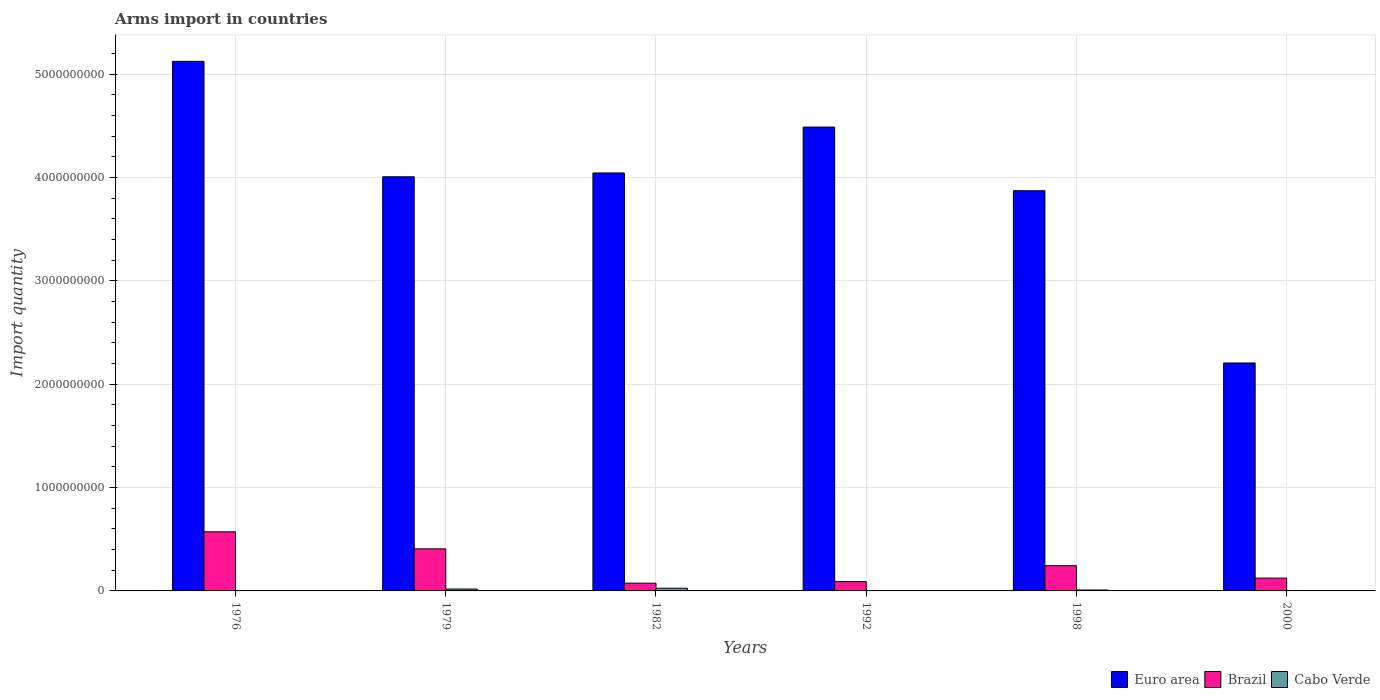How many different coloured bars are there?
Provide a short and direct response. 3. Are the number of bars per tick equal to the number of legend labels?
Your answer should be very brief. Yes. How many bars are there on the 4th tick from the left?
Keep it short and to the point. 3. How many bars are there on the 6th tick from the right?
Provide a succinct answer. 3. What is the label of the 4th group of bars from the left?
Offer a terse response. 1992. In how many cases, is the number of bars for a given year not equal to the number of legend labels?
Keep it short and to the point. 0. What is the total arms import in Brazil in 1982?
Your answer should be compact. 7.50e+07. Across all years, what is the maximum total arms import in Cabo Verde?
Offer a terse response. 2.60e+07. Across all years, what is the minimum total arms import in Euro area?
Provide a succinct answer. 2.21e+09. In which year was the total arms import in Euro area maximum?
Give a very brief answer. 1976. In which year was the total arms import in Euro area minimum?
Offer a terse response. 2000. What is the total total arms import in Brazil in the graph?
Your response must be concise. 1.51e+09. What is the difference between the total arms import in Cabo Verde in 1976 and that in 1982?
Your response must be concise. -2.40e+07. What is the difference between the total arms import in Brazil in 1992 and the total arms import in Euro area in 1979?
Keep it short and to the point. -3.92e+09. What is the average total arms import in Euro area per year?
Your response must be concise. 3.96e+09. In the year 1976, what is the difference between the total arms import in Euro area and total arms import in Brazil?
Keep it short and to the point. 4.55e+09. In how many years, is the total arms import in Euro area greater than 4400000000?
Offer a terse response. 2. What is the ratio of the total arms import in Euro area in 1979 to that in 1982?
Your answer should be very brief. 0.99. What is the difference between the highest and the second highest total arms import in Brazil?
Ensure brevity in your answer.  1.65e+08. What is the difference between the highest and the lowest total arms import in Brazil?
Your response must be concise. 4.97e+08. In how many years, is the total arms import in Brazil greater than the average total arms import in Brazil taken over all years?
Provide a succinct answer. 2. What does the 1st bar from the left in 1992 represents?
Make the answer very short. Euro area. What does the 2nd bar from the right in 1976 represents?
Keep it short and to the point. Brazil. Are the values on the major ticks of Y-axis written in scientific E-notation?
Offer a terse response. No. Does the graph contain grids?
Your answer should be compact. Yes. Where does the legend appear in the graph?
Offer a very short reply. Bottom right. How are the legend labels stacked?
Offer a terse response. Horizontal. What is the title of the graph?
Your answer should be very brief. Arms import in countries. Does "Turks and Caicos Islands" appear as one of the legend labels in the graph?
Your response must be concise. No. What is the label or title of the X-axis?
Make the answer very short. Years. What is the label or title of the Y-axis?
Ensure brevity in your answer.  Import quantity. What is the Import quantity of Euro area in 1976?
Your answer should be very brief. 5.12e+09. What is the Import quantity of Brazil in 1976?
Ensure brevity in your answer.  5.72e+08. What is the Import quantity in Cabo Verde in 1976?
Make the answer very short. 2.00e+06. What is the Import quantity in Euro area in 1979?
Provide a short and direct response. 4.01e+09. What is the Import quantity of Brazil in 1979?
Your answer should be compact. 4.07e+08. What is the Import quantity in Cabo Verde in 1979?
Provide a short and direct response. 1.80e+07. What is the Import quantity of Euro area in 1982?
Make the answer very short. 4.04e+09. What is the Import quantity of Brazil in 1982?
Keep it short and to the point. 7.50e+07. What is the Import quantity in Cabo Verde in 1982?
Your response must be concise. 2.60e+07. What is the Import quantity of Euro area in 1992?
Your answer should be compact. 4.49e+09. What is the Import quantity of Brazil in 1992?
Your response must be concise. 9.00e+07. What is the Import quantity in Euro area in 1998?
Make the answer very short. 3.87e+09. What is the Import quantity in Brazil in 1998?
Provide a short and direct response. 2.44e+08. What is the Import quantity in Cabo Verde in 1998?
Offer a very short reply. 9.00e+06. What is the Import quantity in Euro area in 2000?
Ensure brevity in your answer.  2.21e+09. What is the Import quantity in Brazil in 2000?
Offer a terse response. 1.24e+08. Across all years, what is the maximum Import quantity of Euro area?
Your response must be concise. 5.12e+09. Across all years, what is the maximum Import quantity in Brazil?
Give a very brief answer. 5.72e+08. Across all years, what is the maximum Import quantity of Cabo Verde?
Offer a terse response. 2.60e+07. Across all years, what is the minimum Import quantity in Euro area?
Your answer should be very brief. 2.21e+09. Across all years, what is the minimum Import quantity of Brazil?
Your answer should be very brief. 7.50e+07. Across all years, what is the minimum Import quantity in Cabo Verde?
Provide a short and direct response. 1.00e+06. What is the total Import quantity in Euro area in the graph?
Offer a very short reply. 2.37e+1. What is the total Import quantity in Brazil in the graph?
Offer a very short reply. 1.51e+09. What is the total Import quantity of Cabo Verde in the graph?
Give a very brief answer. 5.90e+07. What is the difference between the Import quantity of Euro area in 1976 and that in 1979?
Offer a terse response. 1.12e+09. What is the difference between the Import quantity in Brazil in 1976 and that in 1979?
Ensure brevity in your answer.  1.65e+08. What is the difference between the Import quantity in Cabo Verde in 1976 and that in 1979?
Offer a terse response. -1.60e+07. What is the difference between the Import quantity of Euro area in 1976 and that in 1982?
Make the answer very short. 1.08e+09. What is the difference between the Import quantity of Brazil in 1976 and that in 1982?
Your answer should be very brief. 4.97e+08. What is the difference between the Import quantity of Cabo Verde in 1976 and that in 1982?
Give a very brief answer. -2.40e+07. What is the difference between the Import quantity of Euro area in 1976 and that in 1992?
Provide a succinct answer. 6.36e+08. What is the difference between the Import quantity of Brazil in 1976 and that in 1992?
Make the answer very short. 4.82e+08. What is the difference between the Import quantity in Cabo Verde in 1976 and that in 1992?
Ensure brevity in your answer.  -1.00e+06. What is the difference between the Import quantity of Euro area in 1976 and that in 1998?
Offer a terse response. 1.25e+09. What is the difference between the Import quantity of Brazil in 1976 and that in 1998?
Provide a short and direct response. 3.28e+08. What is the difference between the Import quantity in Cabo Verde in 1976 and that in 1998?
Provide a succinct answer. -7.00e+06. What is the difference between the Import quantity in Euro area in 1976 and that in 2000?
Offer a terse response. 2.92e+09. What is the difference between the Import quantity in Brazil in 1976 and that in 2000?
Offer a terse response. 4.48e+08. What is the difference between the Import quantity of Cabo Verde in 1976 and that in 2000?
Provide a succinct answer. 1.00e+06. What is the difference between the Import quantity in Euro area in 1979 and that in 1982?
Ensure brevity in your answer.  -3.70e+07. What is the difference between the Import quantity in Brazil in 1979 and that in 1982?
Keep it short and to the point. 3.32e+08. What is the difference between the Import quantity in Cabo Verde in 1979 and that in 1982?
Your answer should be compact. -8.00e+06. What is the difference between the Import quantity of Euro area in 1979 and that in 1992?
Your answer should be very brief. -4.81e+08. What is the difference between the Import quantity of Brazil in 1979 and that in 1992?
Your response must be concise. 3.17e+08. What is the difference between the Import quantity in Cabo Verde in 1979 and that in 1992?
Offer a terse response. 1.50e+07. What is the difference between the Import quantity in Euro area in 1979 and that in 1998?
Your response must be concise. 1.35e+08. What is the difference between the Import quantity of Brazil in 1979 and that in 1998?
Offer a very short reply. 1.63e+08. What is the difference between the Import quantity in Cabo Verde in 1979 and that in 1998?
Your answer should be very brief. 9.00e+06. What is the difference between the Import quantity of Euro area in 1979 and that in 2000?
Provide a succinct answer. 1.80e+09. What is the difference between the Import quantity in Brazil in 1979 and that in 2000?
Offer a very short reply. 2.83e+08. What is the difference between the Import quantity of Cabo Verde in 1979 and that in 2000?
Your answer should be compact. 1.70e+07. What is the difference between the Import quantity of Euro area in 1982 and that in 1992?
Your answer should be compact. -4.44e+08. What is the difference between the Import quantity of Brazil in 1982 and that in 1992?
Provide a succinct answer. -1.50e+07. What is the difference between the Import quantity of Cabo Verde in 1982 and that in 1992?
Your answer should be compact. 2.30e+07. What is the difference between the Import quantity of Euro area in 1982 and that in 1998?
Offer a very short reply. 1.72e+08. What is the difference between the Import quantity of Brazil in 1982 and that in 1998?
Your response must be concise. -1.69e+08. What is the difference between the Import quantity of Cabo Verde in 1982 and that in 1998?
Your answer should be compact. 1.70e+07. What is the difference between the Import quantity of Euro area in 1982 and that in 2000?
Provide a short and direct response. 1.84e+09. What is the difference between the Import quantity in Brazil in 1982 and that in 2000?
Give a very brief answer. -4.90e+07. What is the difference between the Import quantity of Cabo Verde in 1982 and that in 2000?
Provide a succinct answer. 2.50e+07. What is the difference between the Import quantity of Euro area in 1992 and that in 1998?
Keep it short and to the point. 6.16e+08. What is the difference between the Import quantity in Brazil in 1992 and that in 1998?
Keep it short and to the point. -1.54e+08. What is the difference between the Import quantity of Cabo Verde in 1992 and that in 1998?
Your answer should be compact. -6.00e+06. What is the difference between the Import quantity of Euro area in 1992 and that in 2000?
Offer a very short reply. 2.28e+09. What is the difference between the Import quantity in Brazil in 1992 and that in 2000?
Ensure brevity in your answer.  -3.40e+07. What is the difference between the Import quantity in Cabo Verde in 1992 and that in 2000?
Provide a short and direct response. 2.00e+06. What is the difference between the Import quantity of Euro area in 1998 and that in 2000?
Offer a terse response. 1.67e+09. What is the difference between the Import quantity of Brazil in 1998 and that in 2000?
Keep it short and to the point. 1.20e+08. What is the difference between the Import quantity of Cabo Verde in 1998 and that in 2000?
Offer a very short reply. 8.00e+06. What is the difference between the Import quantity in Euro area in 1976 and the Import quantity in Brazil in 1979?
Offer a terse response. 4.72e+09. What is the difference between the Import quantity in Euro area in 1976 and the Import quantity in Cabo Verde in 1979?
Give a very brief answer. 5.11e+09. What is the difference between the Import quantity in Brazil in 1976 and the Import quantity in Cabo Verde in 1979?
Offer a very short reply. 5.54e+08. What is the difference between the Import quantity of Euro area in 1976 and the Import quantity of Brazil in 1982?
Keep it short and to the point. 5.05e+09. What is the difference between the Import quantity of Euro area in 1976 and the Import quantity of Cabo Verde in 1982?
Your answer should be compact. 5.10e+09. What is the difference between the Import quantity of Brazil in 1976 and the Import quantity of Cabo Verde in 1982?
Offer a very short reply. 5.46e+08. What is the difference between the Import quantity of Euro area in 1976 and the Import quantity of Brazil in 1992?
Ensure brevity in your answer.  5.04e+09. What is the difference between the Import quantity of Euro area in 1976 and the Import quantity of Cabo Verde in 1992?
Ensure brevity in your answer.  5.12e+09. What is the difference between the Import quantity in Brazil in 1976 and the Import quantity in Cabo Verde in 1992?
Give a very brief answer. 5.69e+08. What is the difference between the Import quantity in Euro area in 1976 and the Import quantity in Brazil in 1998?
Offer a terse response. 4.88e+09. What is the difference between the Import quantity of Euro area in 1976 and the Import quantity of Cabo Verde in 1998?
Offer a terse response. 5.12e+09. What is the difference between the Import quantity in Brazil in 1976 and the Import quantity in Cabo Verde in 1998?
Make the answer very short. 5.63e+08. What is the difference between the Import quantity of Euro area in 1976 and the Import quantity of Brazil in 2000?
Your answer should be compact. 5.00e+09. What is the difference between the Import quantity in Euro area in 1976 and the Import quantity in Cabo Verde in 2000?
Your answer should be very brief. 5.12e+09. What is the difference between the Import quantity of Brazil in 1976 and the Import quantity of Cabo Verde in 2000?
Make the answer very short. 5.71e+08. What is the difference between the Import quantity in Euro area in 1979 and the Import quantity in Brazil in 1982?
Ensure brevity in your answer.  3.93e+09. What is the difference between the Import quantity in Euro area in 1979 and the Import quantity in Cabo Verde in 1982?
Offer a terse response. 3.98e+09. What is the difference between the Import quantity in Brazil in 1979 and the Import quantity in Cabo Verde in 1982?
Your response must be concise. 3.81e+08. What is the difference between the Import quantity of Euro area in 1979 and the Import quantity of Brazil in 1992?
Keep it short and to the point. 3.92e+09. What is the difference between the Import quantity in Euro area in 1979 and the Import quantity in Cabo Verde in 1992?
Your answer should be compact. 4.00e+09. What is the difference between the Import quantity of Brazil in 1979 and the Import quantity of Cabo Verde in 1992?
Offer a very short reply. 4.04e+08. What is the difference between the Import quantity in Euro area in 1979 and the Import quantity in Brazil in 1998?
Your answer should be very brief. 3.76e+09. What is the difference between the Import quantity in Euro area in 1979 and the Import quantity in Cabo Verde in 1998?
Offer a terse response. 4.00e+09. What is the difference between the Import quantity in Brazil in 1979 and the Import quantity in Cabo Verde in 1998?
Provide a short and direct response. 3.98e+08. What is the difference between the Import quantity of Euro area in 1979 and the Import quantity of Brazil in 2000?
Keep it short and to the point. 3.88e+09. What is the difference between the Import quantity in Euro area in 1979 and the Import quantity in Cabo Verde in 2000?
Offer a terse response. 4.01e+09. What is the difference between the Import quantity in Brazil in 1979 and the Import quantity in Cabo Verde in 2000?
Provide a short and direct response. 4.06e+08. What is the difference between the Import quantity of Euro area in 1982 and the Import quantity of Brazil in 1992?
Your answer should be very brief. 3.96e+09. What is the difference between the Import quantity of Euro area in 1982 and the Import quantity of Cabo Verde in 1992?
Keep it short and to the point. 4.04e+09. What is the difference between the Import quantity in Brazil in 1982 and the Import quantity in Cabo Verde in 1992?
Your answer should be compact. 7.20e+07. What is the difference between the Import quantity in Euro area in 1982 and the Import quantity in Brazil in 1998?
Keep it short and to the point. 3.80e+09. What is the difference between the Import quantity in Euro area in 1982 and the Import quantity in Cabo Verde in 1998?
Your answer should be very brief. 4.04e+09. What is the difference between the Import quantity in Brazil in 1982 and the Import quantity in Cabo Verde in 1998?
Offer a very short reply. 6.60e+07. What is the difference between the Import quantity of Euro area in 1982 and the Import quantity of Brazil in 2000?
Your answer should be very brief. 3.92e+09. What is the difference between the Import quantity of Euro area in 1982 and the Import quantity of Cabo Verde in 2000?
Give a very brief answer. 4.04e+09. What is the difference between the Import quantity of Brazil in 1982 and the Import quantity of Cabo Verde in 2000?
Provide a short and direct response. 7.40e+07. What is the difference between the Import quantity of Euro area in 1992 and the Import quantity of Brazil in 1998?
Offer a terse response. 4.24e+09. What is the difference between the Import quantity of Euro area in 1992 and the Import quantity of Cabo Verde in 1998?
Ensure brevity in your answer.  4.48e+09. What is the difference between the Import quantity of Brazil in 1992 and the Import quantity of Cabo Verde in 1998?
Your response must be concise. 8.10e+07. What is the difference between the Import quantity in Euro area in 1992 and the Import quantity in Brazil in 2000?
Provide a short and direct response. 4.36e+09. What is the difference between the Import quantity in Euro area in 1992 and the Import quantity in Cabo Verde in 2000?
Your answer should be compact. 4.49e+09. What is the difference between the Import quantity in Brazil in 1992 and the Import quantity in Cabo Verde in 2000?
Give a very brief answer. 8.90e+07. What is the difference between the Import quantity of Euro area in 1998 and the Import quantity of Brazil in 2000?
Provide a short and direct response. 3.75e+09. What is the difference between the Import quantity in Euro area in 1998 and the Import quantity in Cabo Verde in 2000?
Offer a very short reply. 3.87e+09. What is the difference between the Import quantity of Brazil in 1998 and the Import quantity of Cabo Verde in 2000?
Provide a succinct answer. 2.43e+08. What is the average Import quantity in Euro area per year?
Provide a short and direct response. 3.96e+09. What is the average Import quantity of Brazil per year?
Keep it short and to the point. 2.52e+08. What is the average Import quantity of Cabo Verde per year?
Offer a very short reply. 9.83e+06. In the year 1976, what is the difference between the Import quantity of Euro area and Import quantity of Brazil?
Your answer should be compact. 4.55e+09. In the year 1976, what is the difference between the Import quantity in Euro area and Import quantity in Cabo Verde?
Provide a short and direct response. 5.12e+09. In the year 1976, what is the difference between the Import quantity in Brazil and Import quantity in Cabo Verde?
Your response must be concise. 5.70e+08. In the year 1979, what is the difference between the Import quantity of Euro area and Import quantity of Brazil?
Make the answer very short. 3.60e+09. In the year 1979, what is the difference between the Import quantity in Euro area and Import quantity in Cabo Verde?
Make the answer very short. 3.99e+09. In the year 1979, what is the difference between the Import quantity of Brazil and Import quantity of Cabo Verde?
Provide a short and direct response. 3.89e+08. In the year 1982, what is the difference between the Import quantity in Euro area and Import quantity in Brazil?
Provide a succinct answer. 3.97e+09. In the year 1982, what is the difference between the Import quantity in Euro area and Import quantity in Cabo Verde?
Ensure brevity in your answer.  4.02e+09. In the year 1982, what is the difference between the Import quantity in Brazil and Import quantity in Cabo Verde?
Offer a terse response. 4.90e+07. In the year 1992, what is the difference between the Import quantity of Euro area and Import quantity of Brazil?
Keep it short and to the point. 4.40e+09. In the year 1992, what is the difference between the Import quantity of Euro area and Import quantity of Cabo Verde?
Offer a terse response. 4.49e+09. In the year 1992, what is the difference between the Import quantity in Brazil and Import quantity in Cabo Verde?
Offer a terse response. 8.70e+07. In the year 1998, what is the difference between the Import quantity of Euro area and Import quantity of Brazil?
Your answer should be compact. 3.63e+09. In the year 1998, what is the difference between the Import quantity in Euro area and Import quantity in Cabo Verde?
Give a very brief answer. 3.86e+09. In the year 1998, what is the difference between the Import quantity in Brazil and Import quantity in Cabo Verde?
Your answer should be compact. 2.35e+08. In the year 2000, what is the difference between the Import quantity of Euro area and Import quantity of Brazil?
Offer a very short reply. 2.08e+09. In the year 2000, what is the difference between the Import quantity in Euro area and Import quantity in Cabo Verde?
Your answer should be compact. 2.20e+09. In the year 2000, what is the difference between the Import quantity in Brazil and Import quantity in Cabo Verde?
Offer a very short reply. 1.23e+08. What is the ratio of the Import quantity in Euro area in 1976 to that in 1979?
Provide a short and direct response. 1.28. What is the ratio of the Import quantity in Brazil in 1976 to that in 1979?
Your answer should be compact. 1.41. What is the ratio of the Import quantity of Cabo Verde in 1976 to that in 1979?
Ensure brevity in your answer.  0.11. What is the ratio of the Import quantity in Euro area in 1976 to that in 1982?
Offer a very short reply. 1.27. What is the ratio of the Import quantity of Brazil in 1976 to that in 1982?
Give a very brief answer. 7.63. What is the ratio of the Import quantity of Cabo Verde in 1976 to that in 1982?
Provide a short and direct response. 0.08. What is the ratio of the Import quantity in Euro area in 1976 to that in 1992?
Ensure brevity in your answer.  1.14. What is the ratio of the Import quantity in Brazil in 1976 to that in 1992?
Your answer should be very brief. 6.36. What is the ratio of the Import quantity in Euro area in 1976 to that in 1998?
Ensure brevity in your answer.  1.32. What is the ratio of the Import quantity in Brazil in 1976 to that in 1998?
Give a very brief answer. 2.34. What is the ratio of the Import quantity in Cabo Verde in 1976 to that in 1998?
Provide a short and direct response. 0.22. What is the ratio of the Import quantity of Euro area in 1976 to that in 2000?
Keep it short and to the point. 2.32. What is the ratio of the Import quantity of Brazil in 1976 to that in 2000?
Provide a succinct answer. 4.61. What is the ratio of the Import quantity of Euro area in 1979 to that in 1982?
Provide a short and direct response. 0.99. What is the ratio of the Import quantity of Brazil in 1979 to that in 1982?
Your answer should be very brief. 5.43. What is the ratio of the Import quantity of Cabo Verde in 1979 to that in 1982?
Ensure brevity in your answer.  0.69. What is the ratio of the Import quantity of Euro area in 1979 to that in 1992?
Ensure brevity in your answer.  0.89. What is the ratio of the Import quantity of Brazil in 1979 to that in 1992?
Your answer should be compact. 4.52. What is the ratio of the Import quantity in Euro area in 1979 to that in 1998?
Provide a short and direct response. 1.03. What is the ratio of the Import quantity of Brazil in 1979 to that in 1998?
Provide a succinct answer. 1.67. What is the ratio of the Import quantity in Euro area in 1979 to that in 2000?
Offer a terse response. 1.82. What is the ratio of the Import quantity in Brazil in 1979 to that in 2000?
Your answer should be very brief. 3.28. What is the ratio of the Import quantity in Euro area in 1982 to that in 1992?
Your answer should be very brief. 0.9. What is the ratio of the Import quantity of Brazil in 1982 to that in 1992?
Provide a short and direct response. 0.83. What is the ratio of the Import quantity of Cabo Verde in 1982 to that in 1992?
Offer a very short reply. 8.67. What is the ratio of the Import quantity in Euro area in 1982 to that in 1998?
Offer a very short reply. 1.04. What is the ratio of the Import quantity in Brazil in 1982 to that in 1998?
Provide a succinct answer. 0.31. What is the ratio of the Import quantity of Cabo Verde in 1982 to that in 1998?
Give a very brief answer. 2.89. What is the ratio of the Import quantity in Euro area in 1982 to that in 2000?
Ensure brevity in your answer.  1.83. What is the ratio of the Import quantity of Brazil in 1982 to that in 2000?
Keep it short and to the point. 0.6. What is the ratio of the Import quantity in Cabo Verde in 1982 to that in 2000?
Your answer should be very brief. 26. What is the ratio of the Import quantity of Euro area in 1992 to that in 1998?
Your response must be concise. 1.16. What is the ratio of the Import quantity in Brazil in 1992 to that in 1998?
Offer a terse response. 0.37. What is the ratio of the Import quantity in Euro area in 1992 to that in 2000?
Provide a succinct answer. 2.03. What is the ratio of the Import quantity of Brazil in 1992 to that in 2000?
Offer a very short reply. 0.73. What is the ratio of the Import quantity in Euro area in 1998 to that in 2000?
Your response must be concise. 1.76. What is the ratio of the Import quantity in Brazil in 1998 to that in 2000?
Offer a terse response. 1.97. What is the ratio of the Import quantity in Cabo Verde in 1998 to that in 2000?
Offer a terse response. 9. What is the difference between the highest and the second highest Import quantity of Euro area?
Your answer should be compact. 6.36e+08. What is the difference between the highest and the second highest Import quantity of Brazil?
Your answer should be very brief. 1.65e+08. What is the difference between the highest and the second highest Import quantity in Cabo Verde?
Offer a very short reply. 8.00e+06. What is the difference between the highest and the lowest Import quantity in Euro area?
Provide a short and direct response. 2.92e+09. What is the difference between the highest and the lowest Import quantity of Brazil?
Your answer should be very brief. 4.97e+08. What is the difference between the highest and the lowest Import quantity in Cabo Verde?
Ensure brevity in your answer.  2.50e+07. 